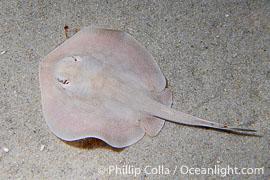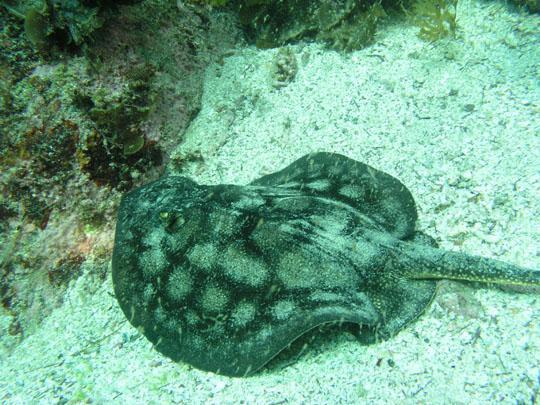The first image is the image on the left, the second image is the image on the right. For the images displayed, is the sentence "In the left image, there's a single round stingray facing the lower right." factually correct? Answer yes or no. No. The first image is the image on the left, the second image is the image on the right. For the images displayed, is the sentence "In at least one image a stingray's spine points to the 10:00 position." factually correct? Answer yes or no. No. 